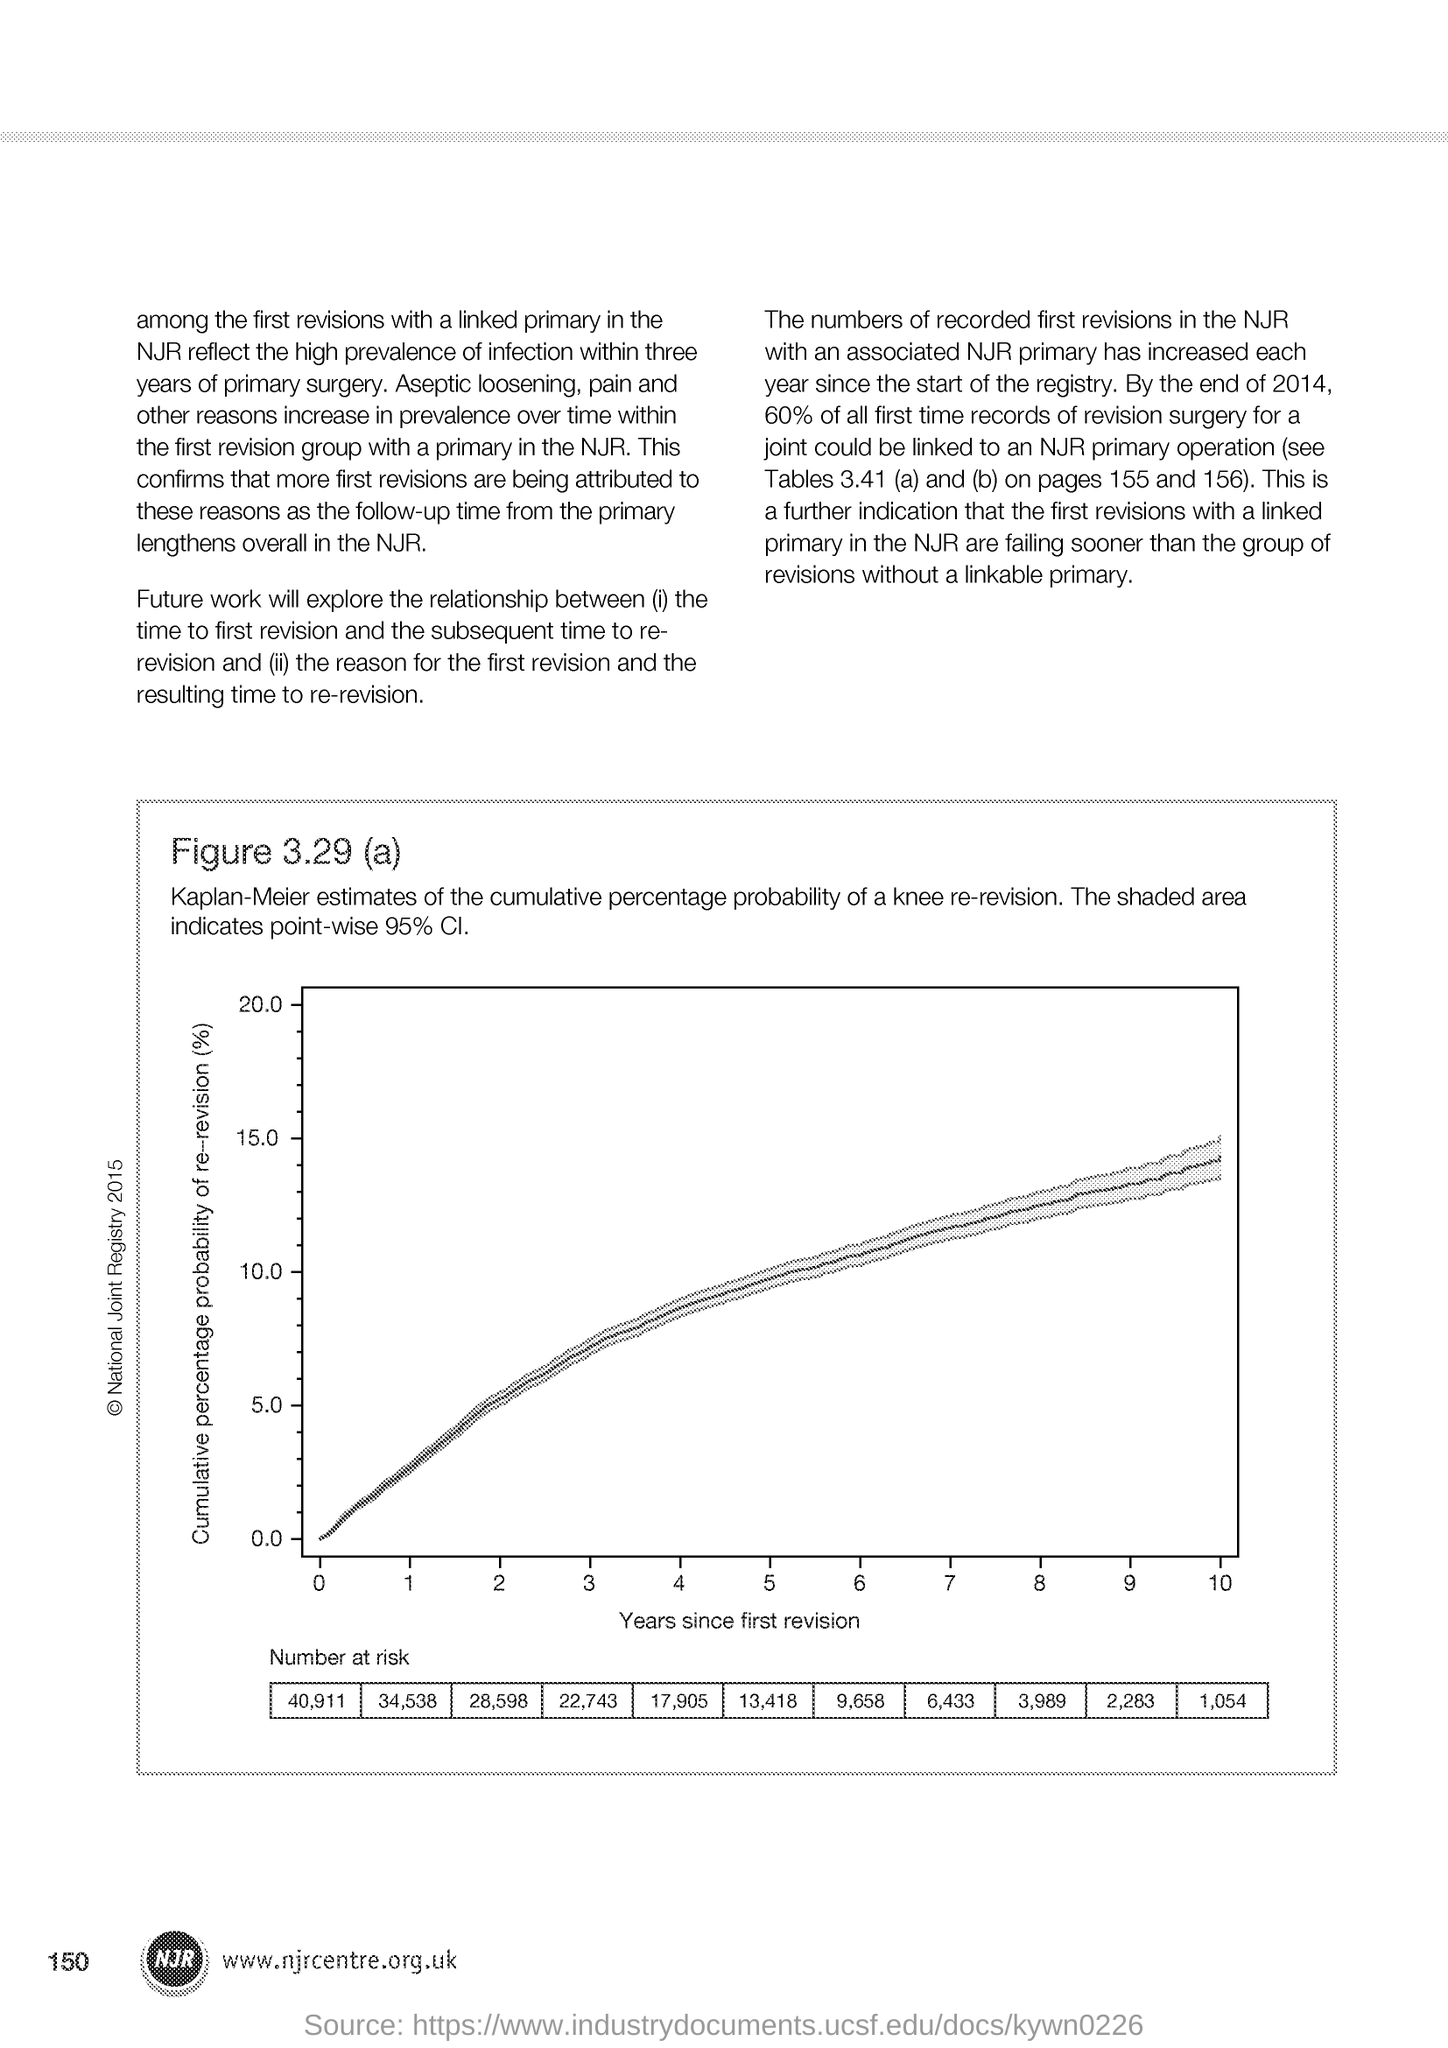Draw attention to some important aspects in this diagram. The page number is 150. The x-axis in the figure shows the number of years that have passed since the initial revision of the manuscript. 